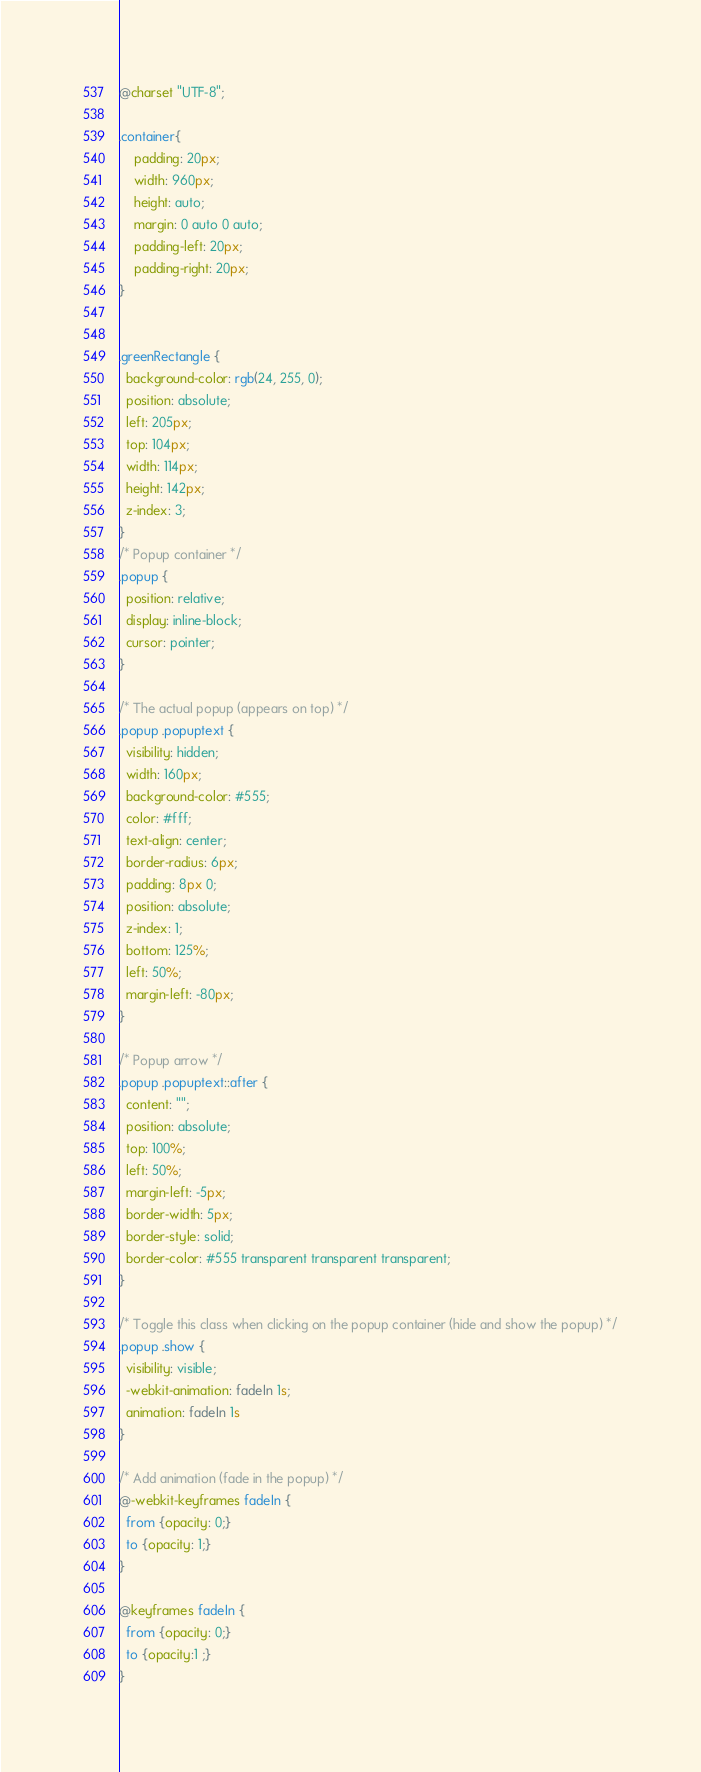Convert code to text. <code><loc_0><loc_0><loc_500><loc_500><_CSS_>@charset "UTF-8";

.container{
	padding: 20px;
    width: 960px;
    height: auto;
    margin: 0 auto 0 auto;
	padding-left: 20px;
	padding-right: 20px;
}	


.greenRectangle {
  background-color: rgb(24, 255, 0);
  position: absolute;
  left: 205px;
  top: 104px;
  width: 114px;
  height: 142px;
  z-index: 3;
}
/* Popup container */
.popup {
  position: relative;
  display: inline-block;
  cursor: pointer;
}

/* The actual popup (appears on top) */
.popup .popuptext {
  visibility: hidden;
  width: 160px;
  background-color: #555;
  color: #fff;
  text-align: center;
  border-radius: 6px;
  padding: 8px 0;
  position: absolute;
  z-index: 1;
  bottom: 125%;
  left: 50%;
  margin-left: -80px;
}

/* Popup arrow */
.popup .popuptext::after {
  content: "";
  position: absolute;
  top: 100%;
  left: 50%;
  margin-left: -5px;
  border-width: 5px;
  border-style: solid;
  border-color: #555 transparent transparent transparent;
}

/* Toggle this class when clicking on the popup container (hide and show the popup) */
.popup .show {
  visibility: visible;
  -webkit-animation: fadeIn 1s;
  animation: fadeIn 1s
}

/* Add animation (fade in the popup) */
@-webkit-keyframes fadeIn {
  from {opacity: 0;}
  to {opacity: 1;}
}

@keyframes fadeIn {
  from {opacity: 0;}
  to {opacity:1 ;}
}</code> 